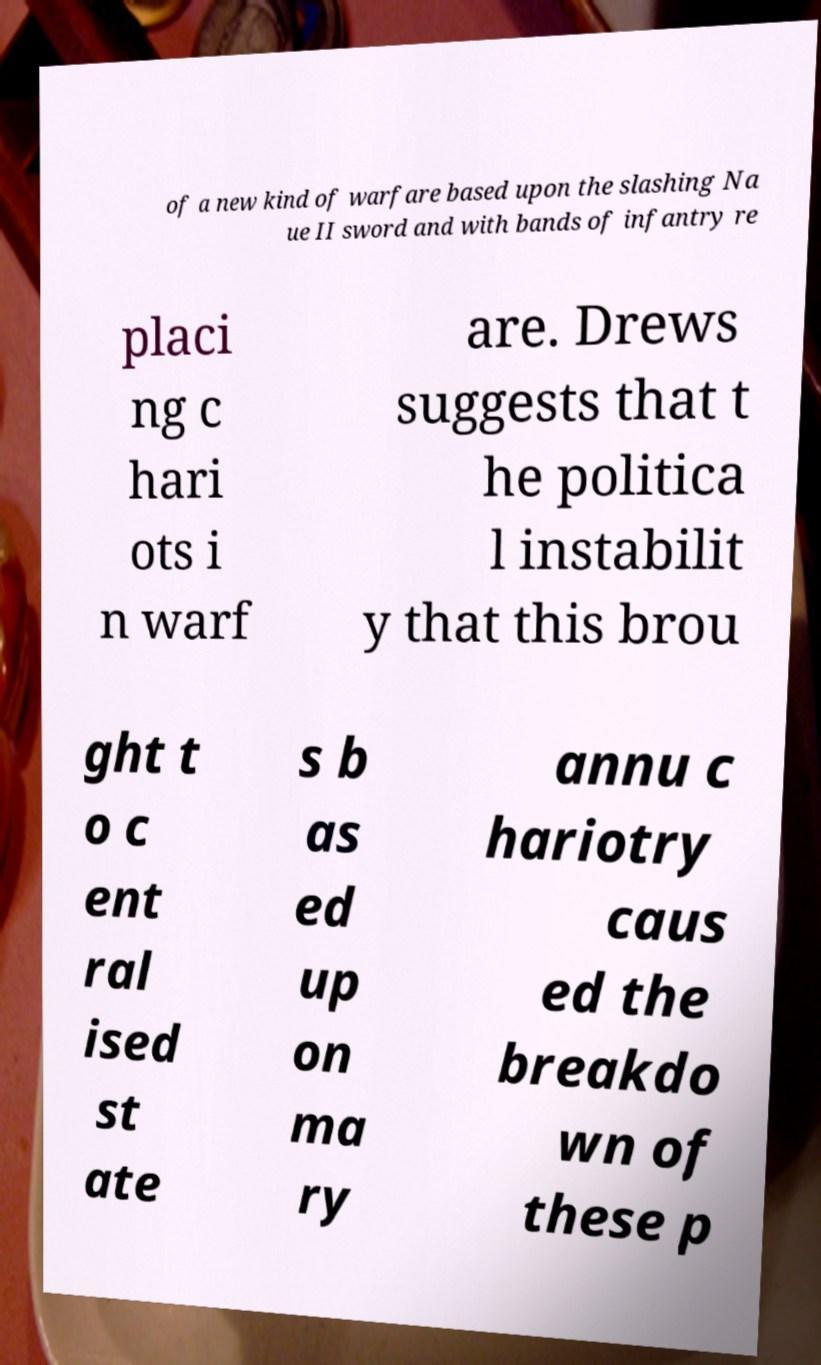Please read and relay the text visible in this image. What does it say? of a new kind of warfare based upon the slashing Na ue II sword and with bands of infantry re placi ng c hari ots i n warf are. Drews suggests that t he politica l instabilit y that this brou ght t o c ent ral ised st ate s b as ed up on ma ry annu c hariotry caus ed the breakdo wn of these p 